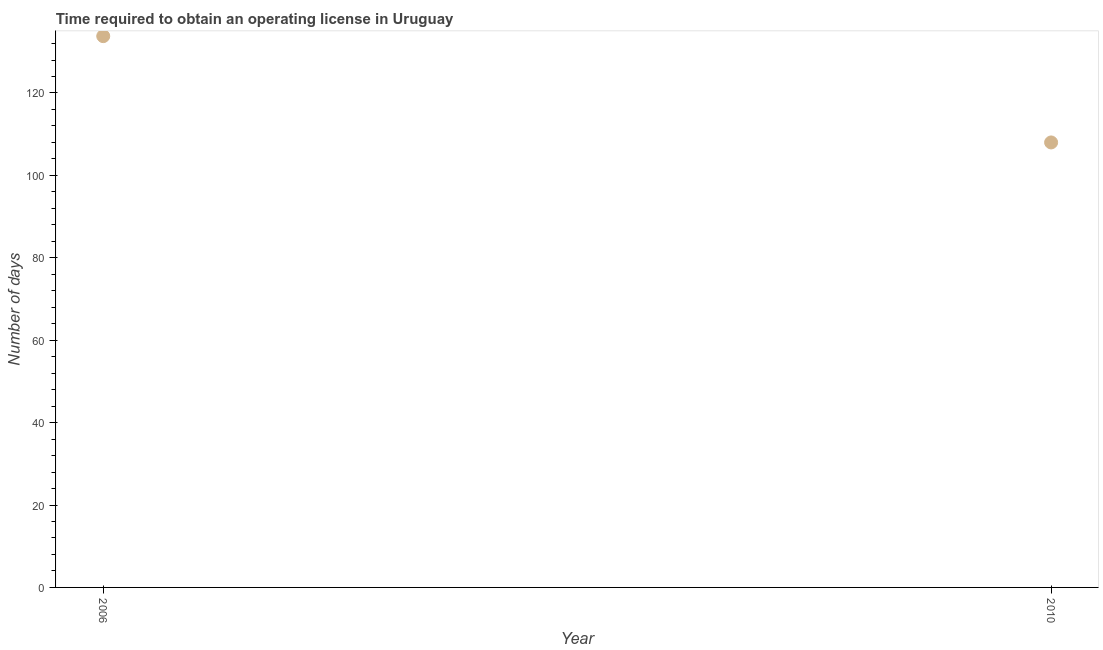What is the number of days to obtain operating license in 2010?
Make the answer very short. 108. Across all years, what is the maximum number of days to obtain operating license?
Provide a short and direct response. 133.8. Across all years, what is the minimum number of days to obtain operating license?
Provide a short and direct response. 108. In which year was the number of days to obtain operating license minimum?
Make the answer very short. 2010. What is the sum of the number of days to obtain operating license?
Offer a very short reply. 241.8. What is the difference between the number of days to obtain operating license in 2006 and 2010?
Your response must be concise. 25.8. What is the average number of days to obtain operating license per year?
Offer a terse response. 120.9. What is the median number of days to obtain operating license?
Give a very brief answer. 120.9. Do a majority of the years between 2006 and 2010 (inclusive) have number of days to obtain operating license greater than 20 days?
Make the answer very short. Yes. What is the ratio of the number of days to obtain operating license in 2006 to that in 2010?
Your answer should be compact. 1.24. Does the number of days to obtain operating license monotonically increase over the years?
Provide a short and direct response. No. How many dotlines are there?
Keep it short and to the point. 1. What is the title of the graph?
Your response must be concise. Time required to obtain an operating license in Uruguay. What is the label or title of the Y-axis?
Your answer should be very brief. Number of days. What is the Number of days in 2006?
Offer a very short reply. 133.8. What is the Number of days in 2010?
Ensure brevity in your answer.  108. What is the difference between the Number of days in 2006 and 2010?
Your answer should be very brief. 25.8. What is the ratio of the Number of days in 2006 to that in 2010?
Your answer should be compact. 1.24. 